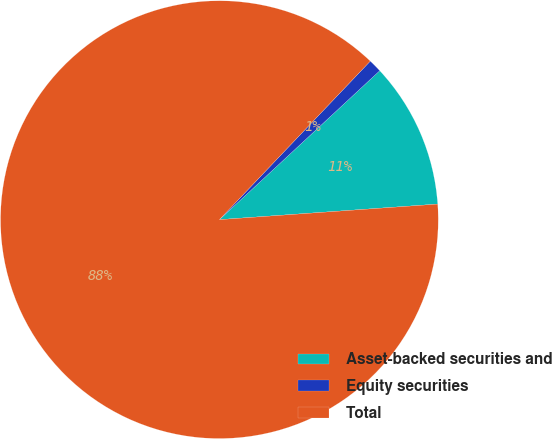Convert chart. <chart><loc_0><loc_0><loc_500><loc_500><pie_chart><fcel>Asset-backed securities and<fcel>Equity securities<fcel>Total<nl><fcel>10.78%<fcel>0.98%<fcel>88.24%<nl></chart> 